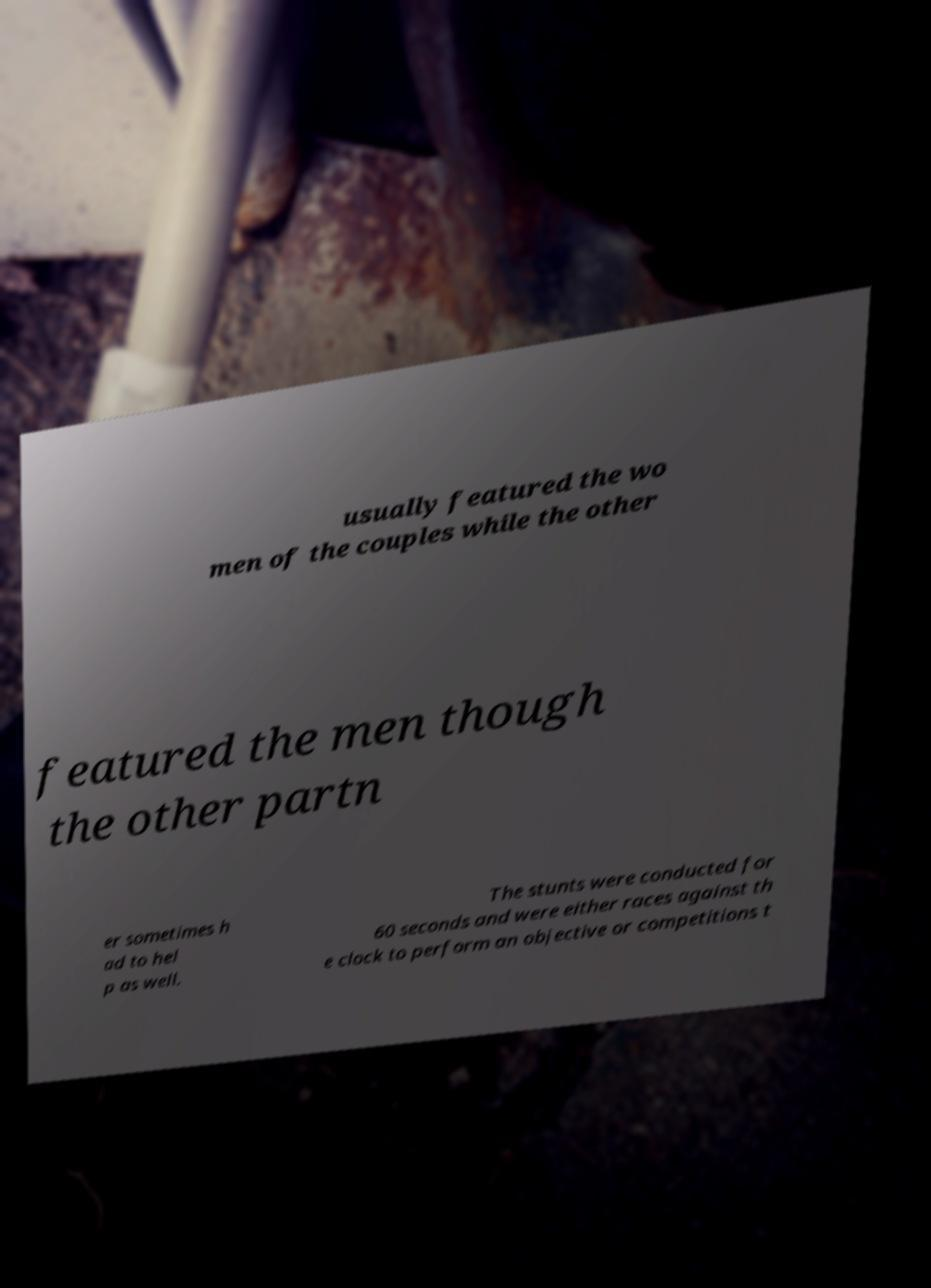What messages or text are displayed in this image? I need them in a readable, typed format. usually featured the wo men of the couples while the other featured the men though the other partn er sometimes h ad to hel p as well. The stunts were conducted for 60 seconds and were either races against th e clock to perform an objective or competitions t 